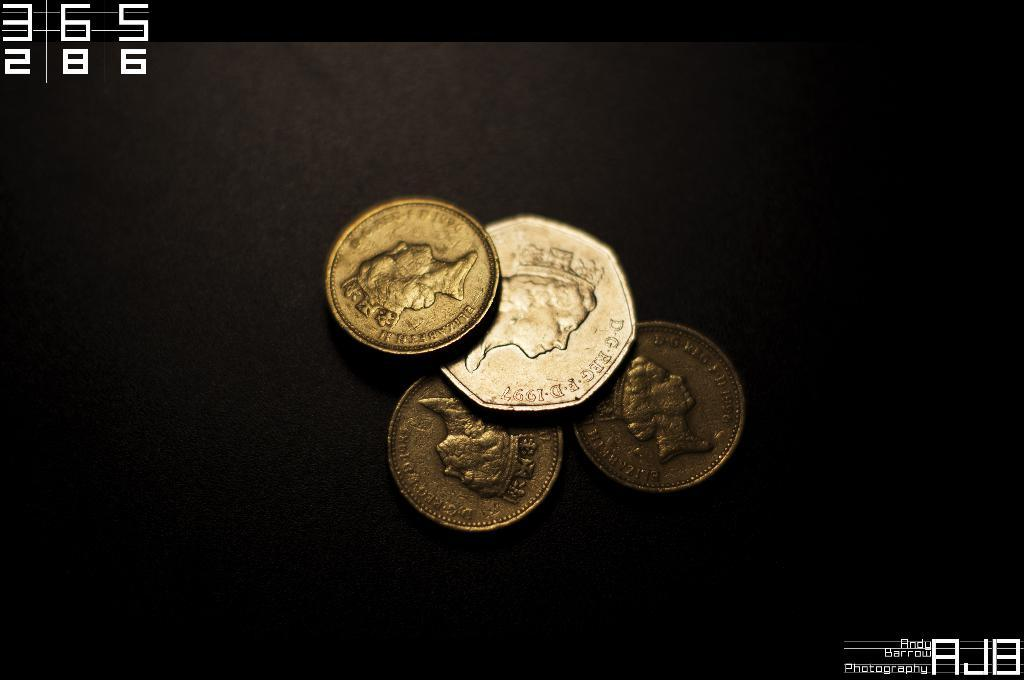<image>
Offer a succinct explanation of the picture presented. Four gold coins on top of one another and one saying Elizabeth. 